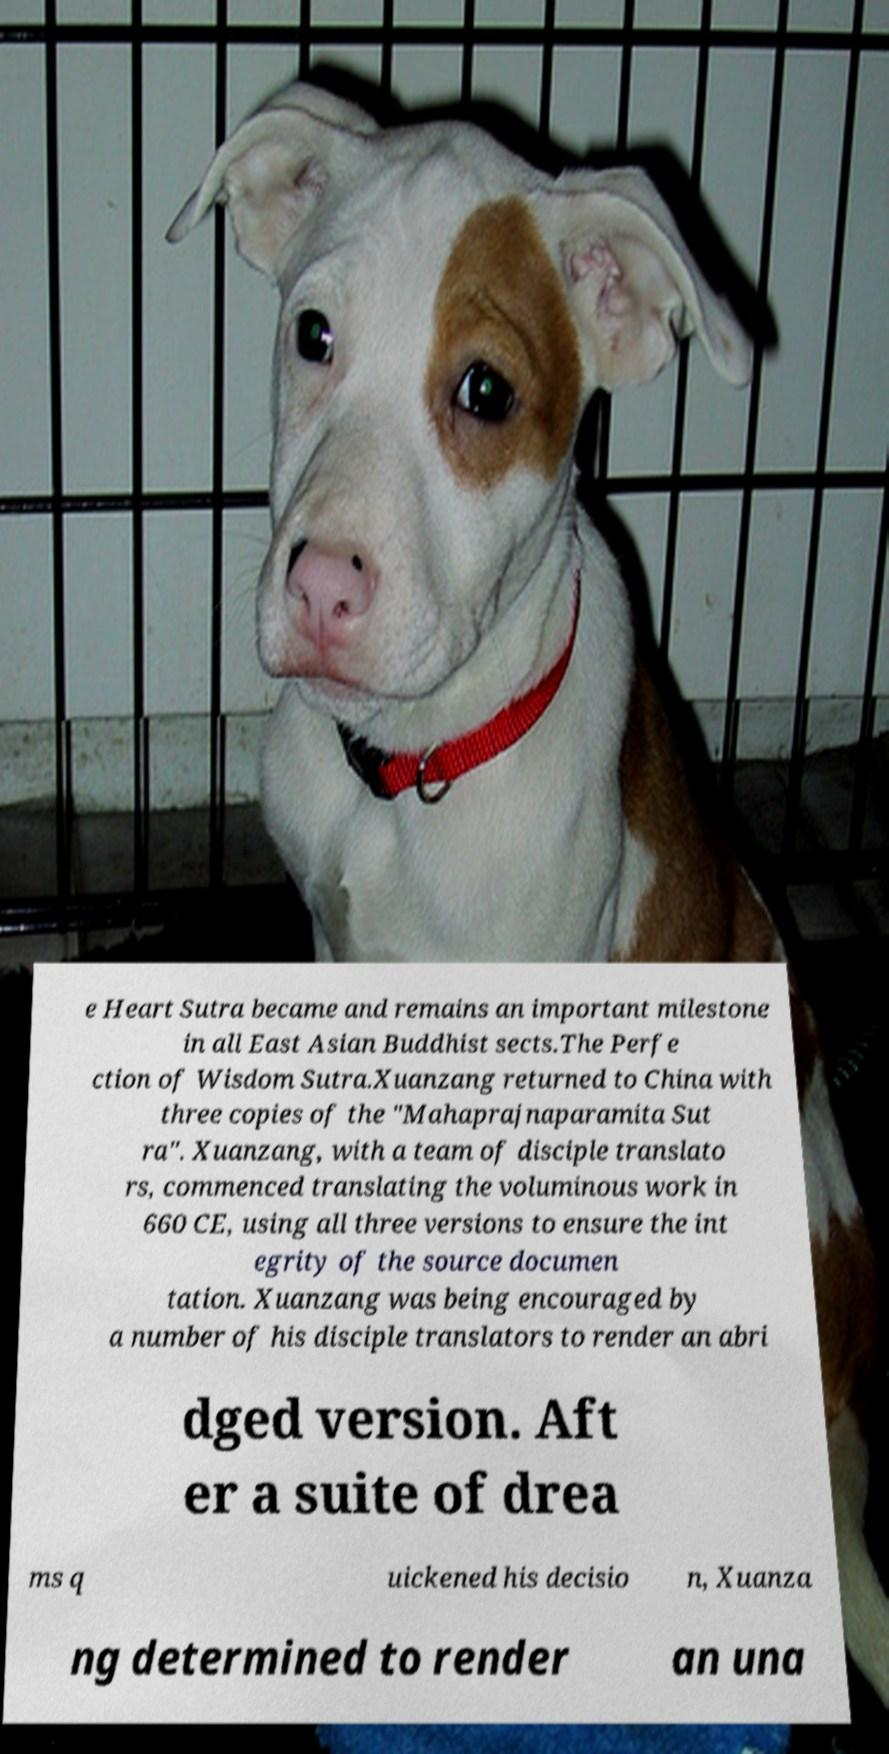Can you accurately transcribe the text from the provided image for me? e Heart Sutra became and remains an important milestone in all East Asian Buddhist sects.The Perfe ction of Wisdom Sutra.Xuanzang returned to China with three copies of the "Mahaprajnaparamita Sut ra". Xuanzang, with a team of disciple translato rs, commenced translating the voluminous work in 660 CE, using all three versions to ensure the int egrity of the source documen tation. Xuanzang was being encouraged by a number of his disciple translators to render an abri dged version. Aft er a suite of drea ms q uickened his decisio n, Xuanza ng determined to render an una 